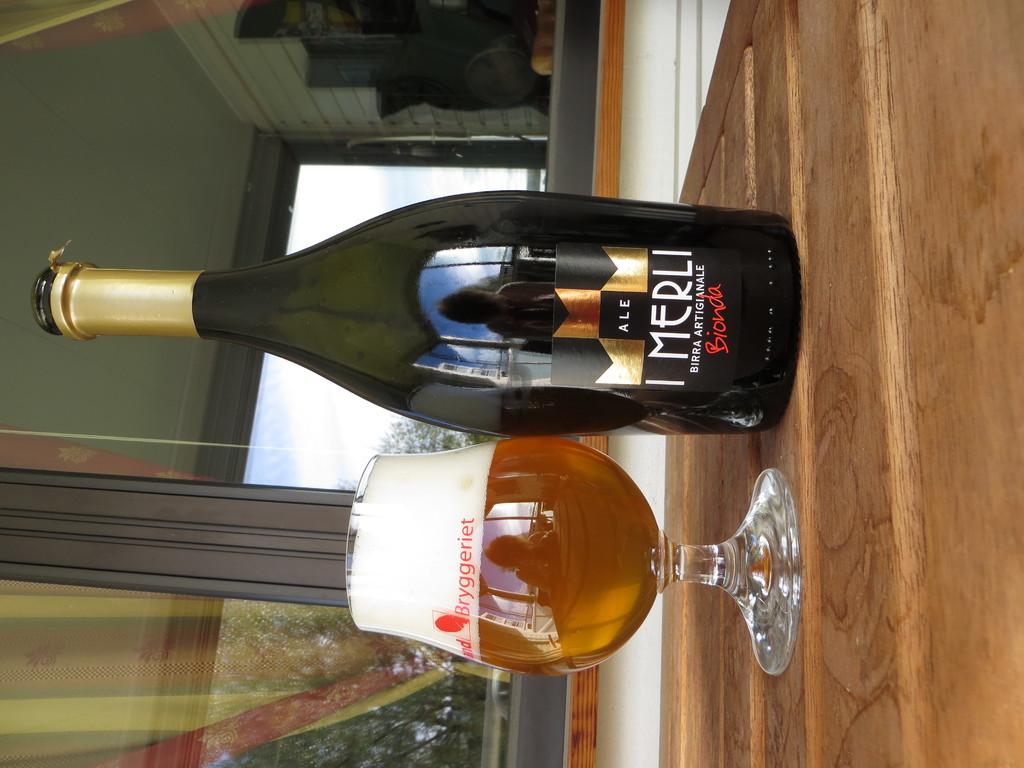What kind of ale is in the glass?
Make the answer very short. Merli. What brand is the ale?
Give a very brief answer. I merli. 